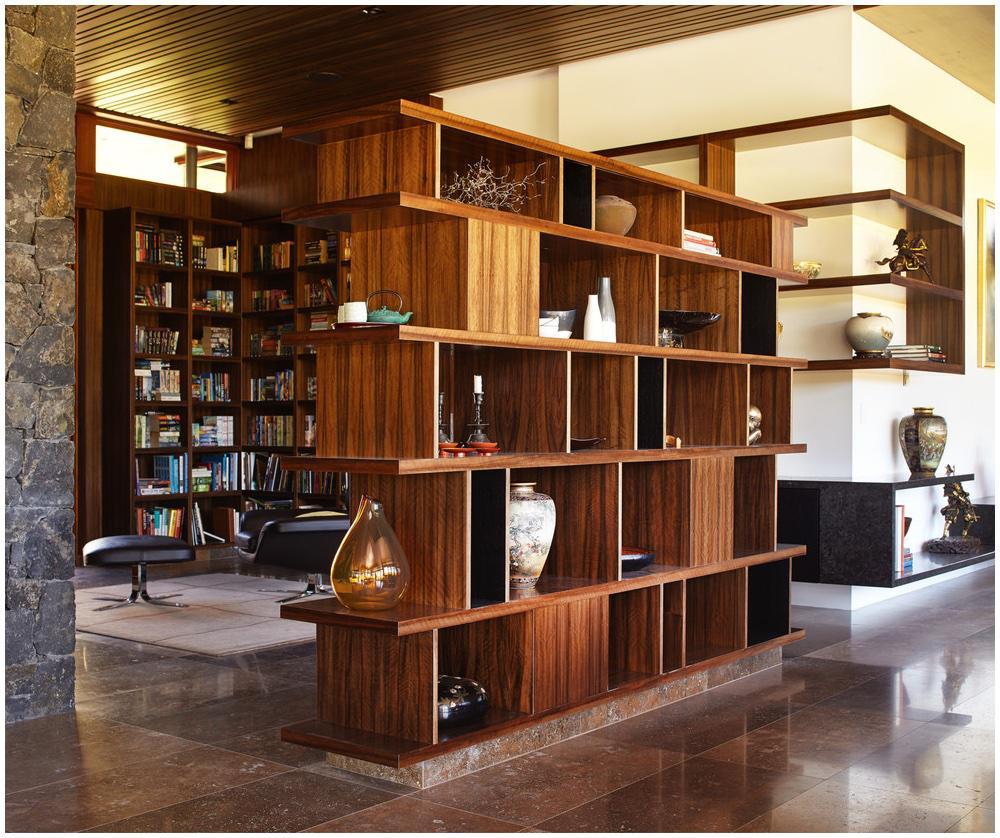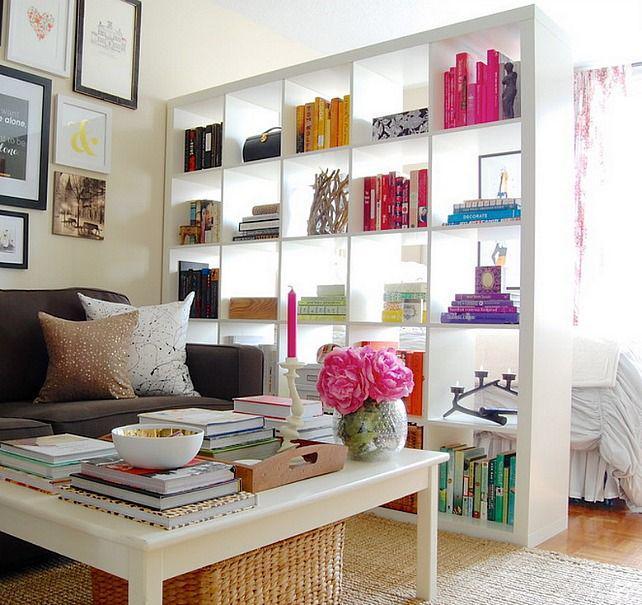The first image is the image on the left, the second image is the image on the right. Examine the images to the left and right. Is the description "Some of the shelving is white and a vase of pink flowers is on a sofa coffee table in one of the images." accurate? Answer yes or no. Yes. The first image is the image on the left, the second image is the image on the right. Considering the images on both sides, is "One image has a coffee table and couch in front of a book case." valid? Answer yes or no. Yes. 